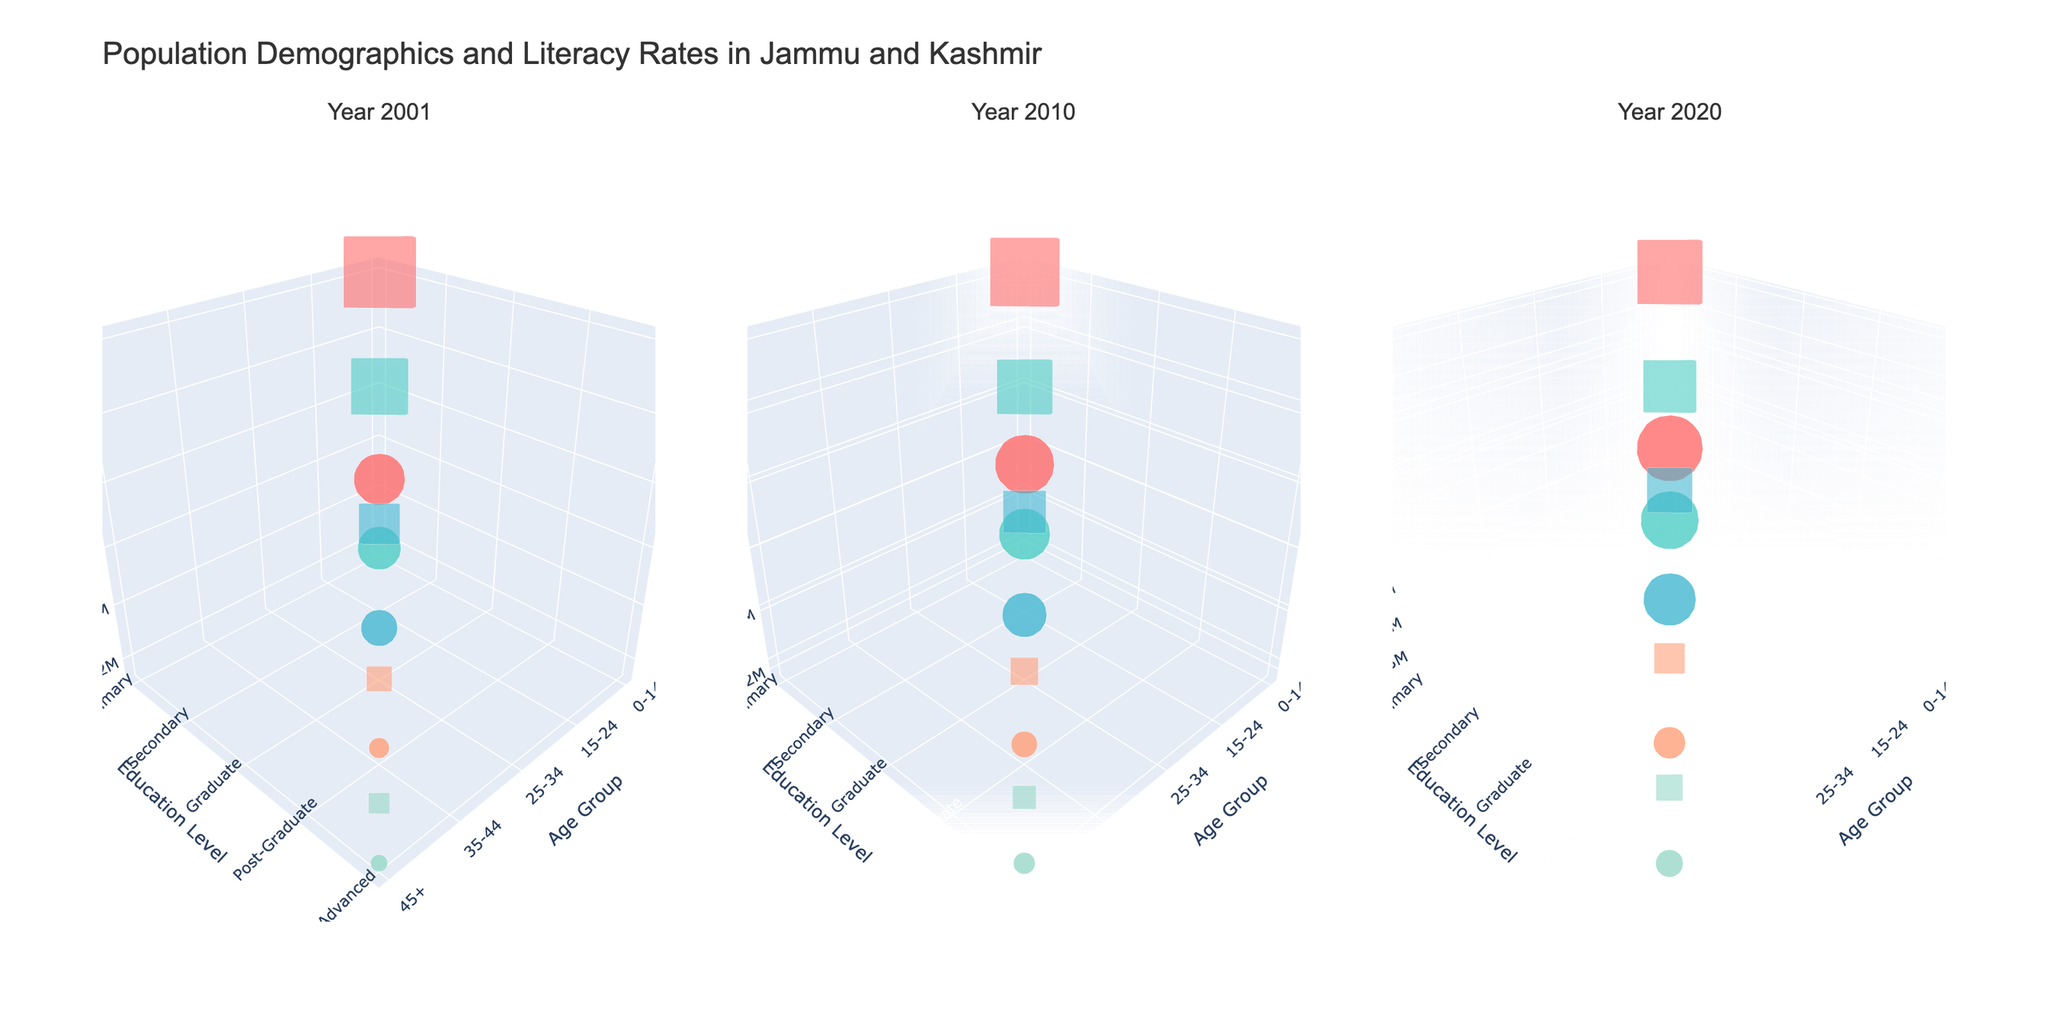What is the trend in urban literacy rates across different age groups from 2001 to 2020? Observe the plotted points in the figure for urban markers over time and compare their literacy rate texts. Notice how literacy rates have increased for all age groups, indicating an upward trend.
Answer: Increasing trend How do urban and rural populations compare in the 0-14 age group for the year 2020? Look at the sizes of the markers representing urban and rural populations for 0-14 in 2020. The urban population marker is smaller than the rural one.
Answer: Urban populations smaller What are the literacy rates for the 25-34 age group in urban areas for each year shown in the plot? Check the hover texts for urban markers in the 25-34 age group across all subplots. The literacy rates mentioned are 82.1% in 2001, 87.6% in 2010, and 92.3% in 2020.
Answer: 82.1%, 87.6%, 92.3% Which age group has the highest rural literacy rate in the year 2020? Refer to the hover texts for rural markers in 2020 and compare literacy rates across all age groups. The highest literacy rate, 82.9%, is found in the 35-44 age group.
Answer: 35-44 Compare the change in urban population between 0-14 and 15-24 age groups from 2001 to 2020. Identify the urban population markers for both age groups in 2001 and 2020. For 0-14, the population changes from 450,000 to 580,000 (an increase of 130,000). For 15-24, the population changes from 380,000 to 510,000 (an increase of 130,000). Thus, both age groups have the same increase in urban population.
Answer: Same increase (130,000) What is the trend in rural literacy rates for the age group 45+ from 2001 to 2020? Look at the hover texts for rural markers in the 45+ age group across the subplots. The literacy rates mentioned increase from 59.8% in 2001, to 69.5% in 2010, and 78.7% in 2020, indicating an upward trend.
Answer: Increasing trend Identify the educational level with the highest urban population in each year. For each subplot (2001, 2010, 2020), compare the sizes and hover texts of urban markers to determine the highest urban population. In 2001, the primary level has the highest urban population. In 2010, it is the primary level again, and in 2020, it is also the primary level.
Answer: Primary Among the urban populations, which year shows the highest literacy rate for the 15-24 age group? Check the hover texts for urban markers in the 15-24 age group for each year. The highest literacy rate is 89.7% in the year 2020.
Answer: 2020 What is the least rural population among all age groups and educational levels in 2001? Examine the smallest rural marker for 2001, considering any text information for exact populations. The smallest rural population is in the 45+ age group with Advanced education, totaling 350,000.
Answer: 350,000 How have the literacy rates for urban compared to rural populations in the age group 35-44 changed between 2001 and 2020? Compare literacy rates for urban and rural markers in the 35-44 age group between 2001 and 2020. Urban literacy increased from 85.3% to 93.8%, while rural literacy increased from 64.2% to 82.9%. Both have significantly increased, with urban rates being consistently higher.
Answer: Both increased, urban consistently higher 